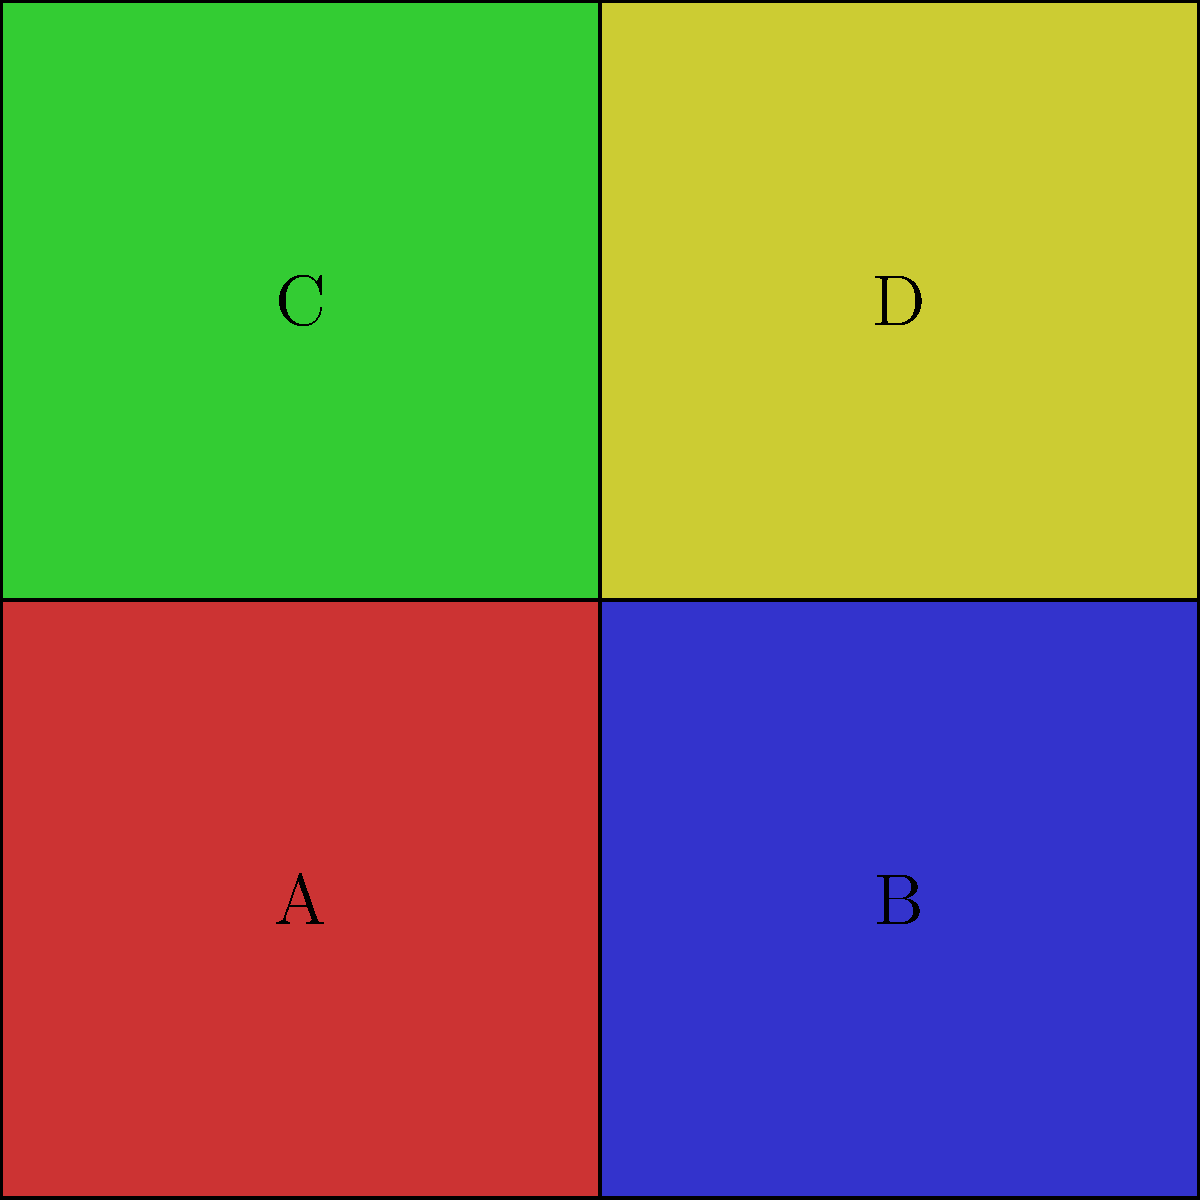After redistricting, the electoral map has been redrawn as shown above. If the party in control of district A wants to maximize its influence, which district should it propose to merge with to create a larger, combined district? To answer this question, we need to consider the strategic implications of merging districts in the context of partisan redistricting:

1. District A is currently controlled by one party (let's call it Party X).

2. The goal is to maximize Party X's influence through redistricting.

3. Examining the options:
   - Merging with B: This would create a horizontally elongated district.
   - Merging with C: This would create a vertically elongated district.
   - Merging with D: This would create a diagonally connected district.

4. In partisan redistricting, a common strategy is to concentrate opposition voters into as few districts as possible, while spreading out friendly voters across more districts.

5. Assuming the colors represent voter preferences, district A (red) likely has a high concentration of Party X voters.

6. The best strategy would be to merge with a district that has a mix of voters or a slight lean towards Party X, allowing Party X to potentially control two districts instead of one.

7. Based on the colors, district C (green) appears to be the most different from A, suggesting it might have the highest concentration of opposition voters.

8. Districts B (blue) and D (yellow) are more moderate in color, indicating a potentially more mixed voter base.

9. Of these two, D is diagonally connected, which might be seen as less natural and more obviously gerrymandered.

10. Therefore, merging with B would be the most strategic choice, as it creates a more natural-looking district while potentially allowing Party X to control both the merged district and maintain influence in C and D.
Answer: District B 